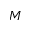<formula> <loc_0><loc_0><loc_500><loc_500>M</formula> 